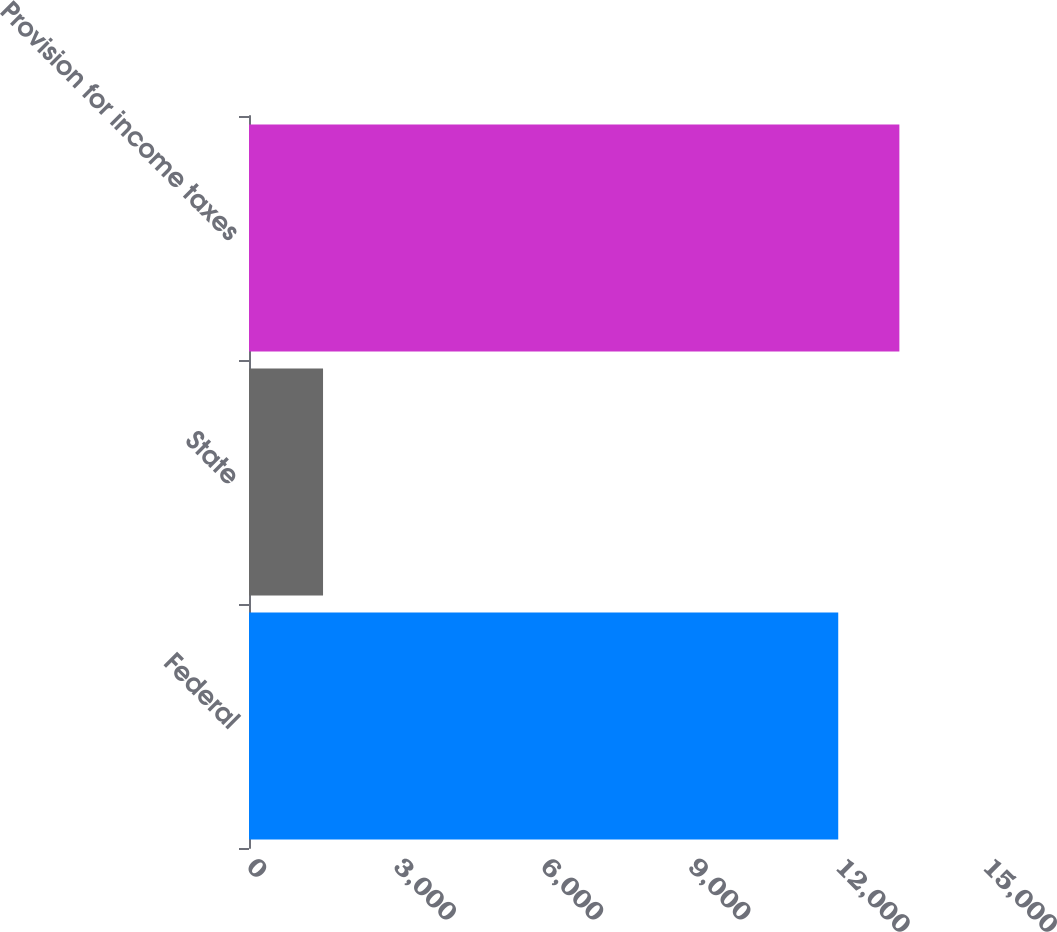Convert chart. <chart><loc_0><loc_0><loc_500><loc_500><bar_chart><fcel>Federal<fcel>State<fcel>Provision for income taxes<nl><fcel>12009<fcel>1509<fcel>13255<nl></chart> 